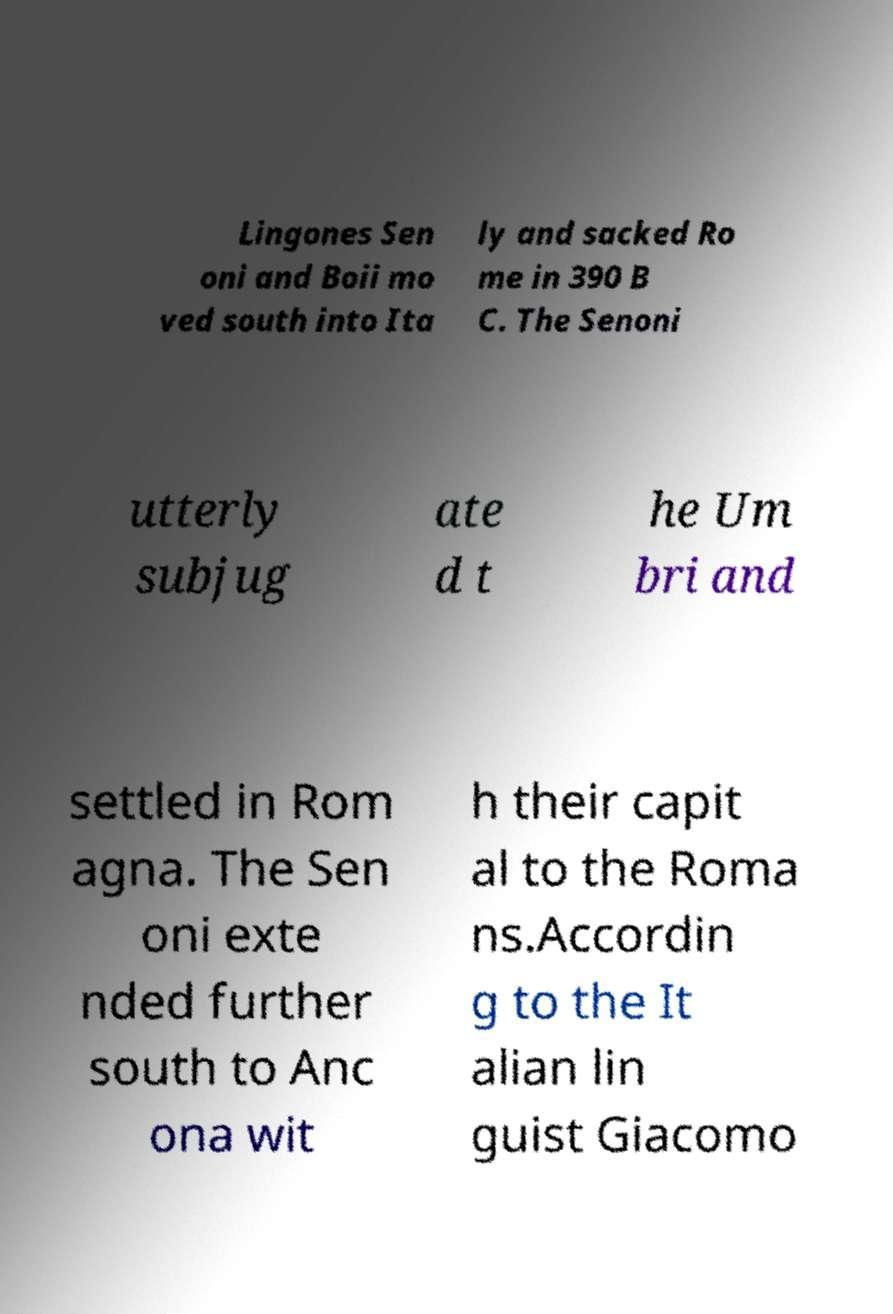Please read and relay the text visible in this image. What does it say? Lingones Sen oni and Boii mo ved south into Ita ly and sacked Ro me in 390 B C. The Senoni utterly subjug ate d t he Um bri and settled in Rom agna. The Sen oni exte nded further south to Anc ona wit h their capit al to the Roma ns.Accordin g to the It alian lin guist Giacomo 